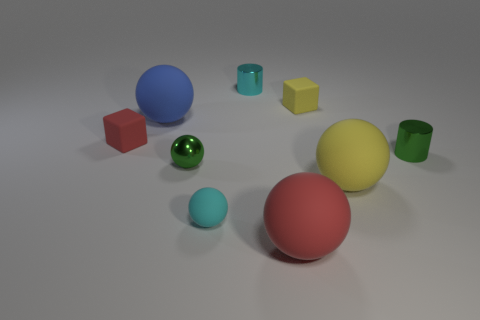The green cylinder is what size?
Your response must be concise. Small. There is a metallic object that is the same shape as the cyan matte object; what color is it?
Your answer should be very brief. Green. There is a matte thing behind the big blue rubber object; does it have the same size as the red matte thing that is in front of the big yellow matte sphere?
Your response must be concise. No. Are there any small green objects of the same shape as the cyan shiny thing?
Offer a terse response. Yes. Are there the same number of tiny red blocks that are to the right of the big blue rubber sphere and small cyan balls?
Your response must be concise. No. Do the metallic sphere and the cube right of the small red thing have the same size?
Your answer should be very brief. Yes. How many big blue spheres have the same material as the blue thing?
Your answer should be very brief. 0. Do the cyan metallic thing and the blue matte thing have the same size?
Make the answer very short. No. Are there any other things that are the same color as the tiny shiny sphere?
Give a very brief answer. Yes. What shape is the shiny object that is both in front of the tiny yellow rubber object and left of the big red matte sphere?
Your answer should be very brief. Sphere. 